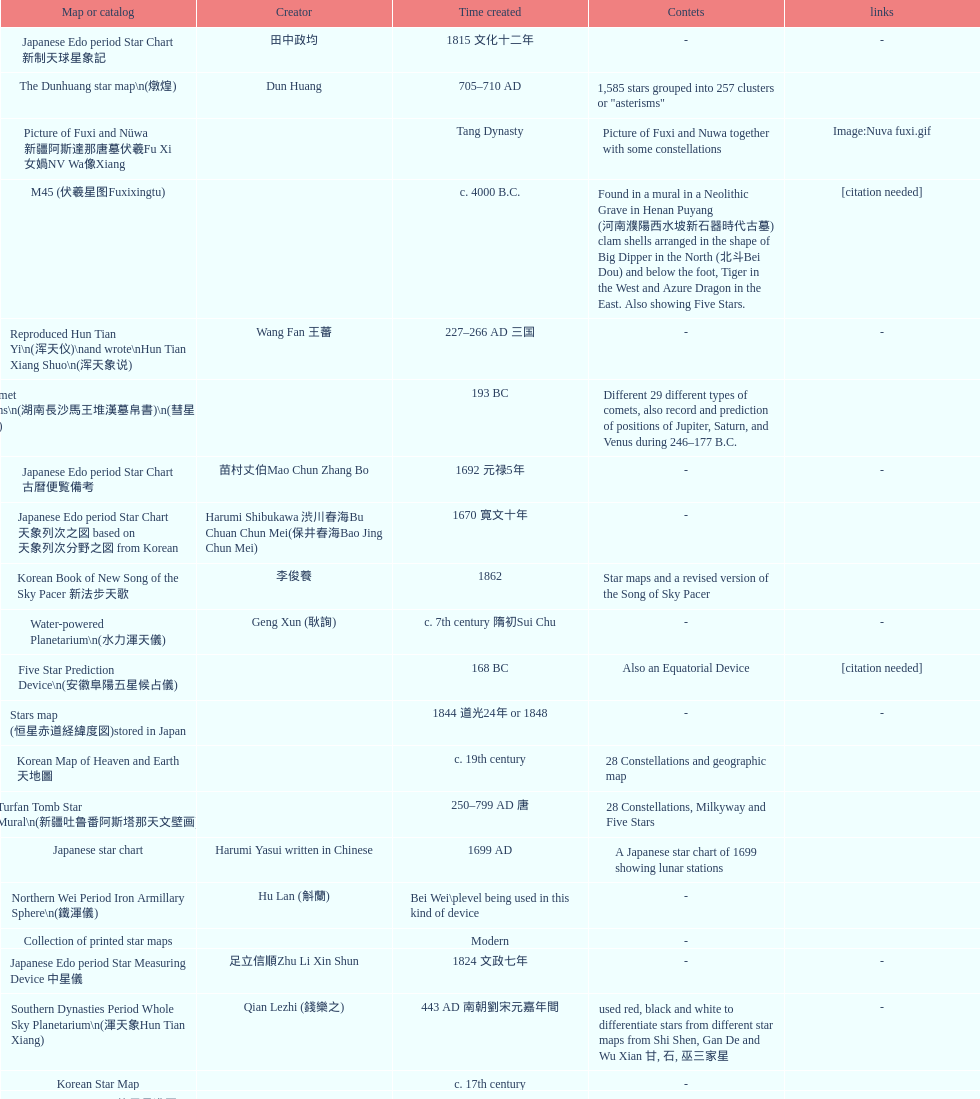Which map or catalog was created last? Sky in Google Earth KML. 